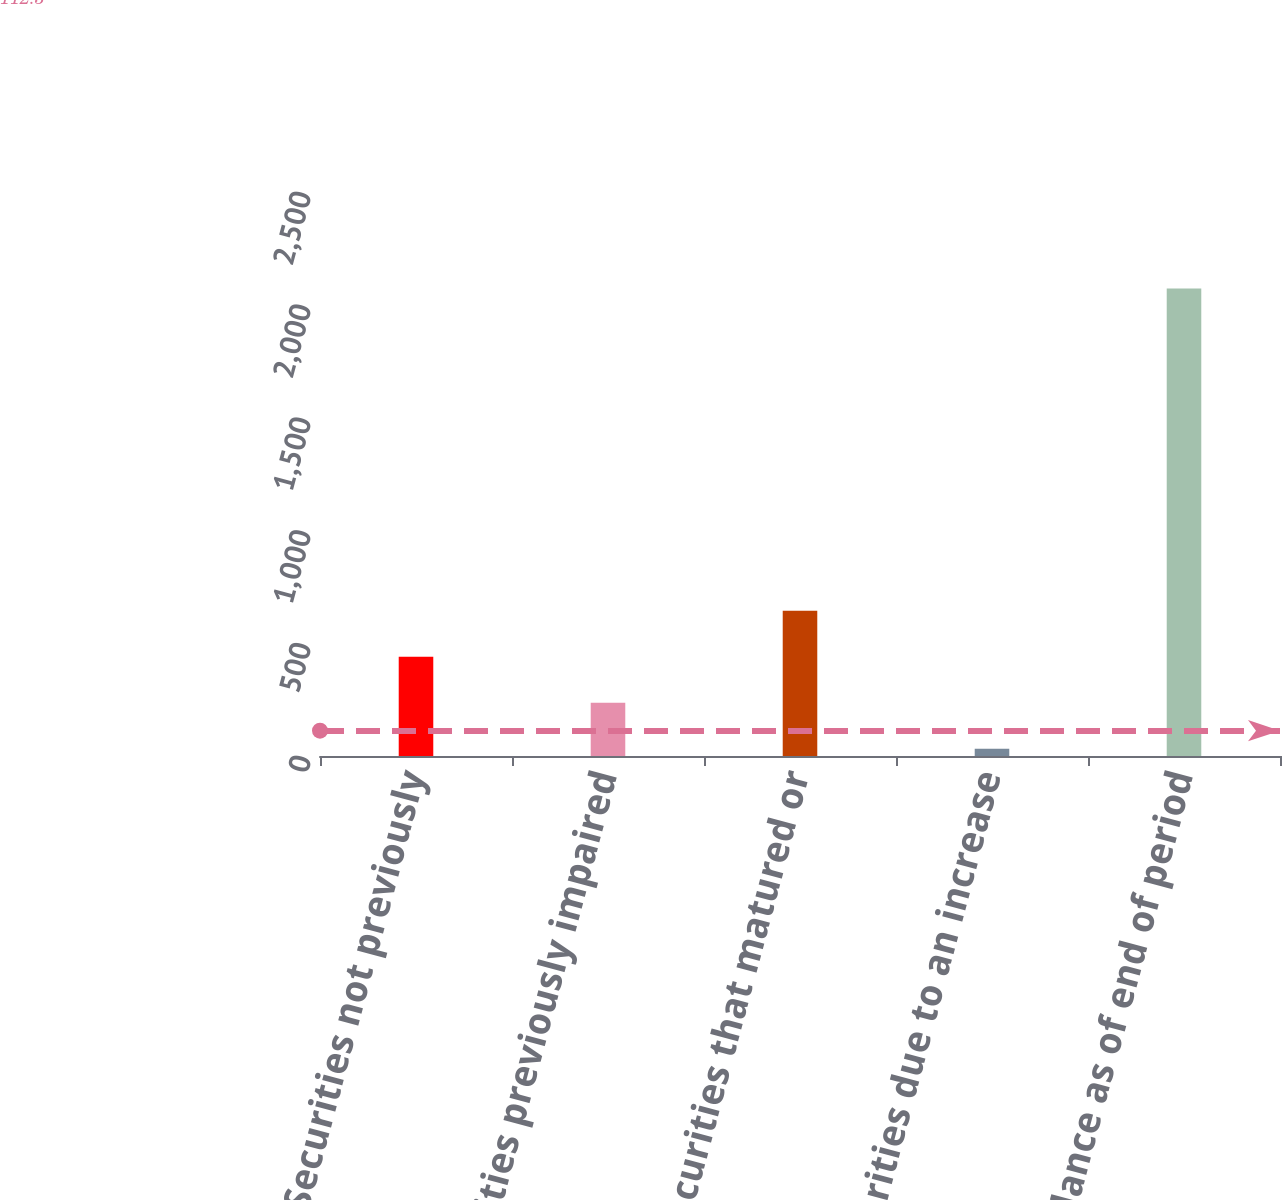<chart> <loc_0><loc_0><loc_500><loc_500><bar_chart><fcel>Securities not previously<fcel>Securities previously impaired<fcel>Securities that matured or<fcel>Securities due to an increase<fcel>Balance as of end of period<nl><fcel>440<fcel>236<fcel>644<fcel>32<fcel>2072<nl></chart> 